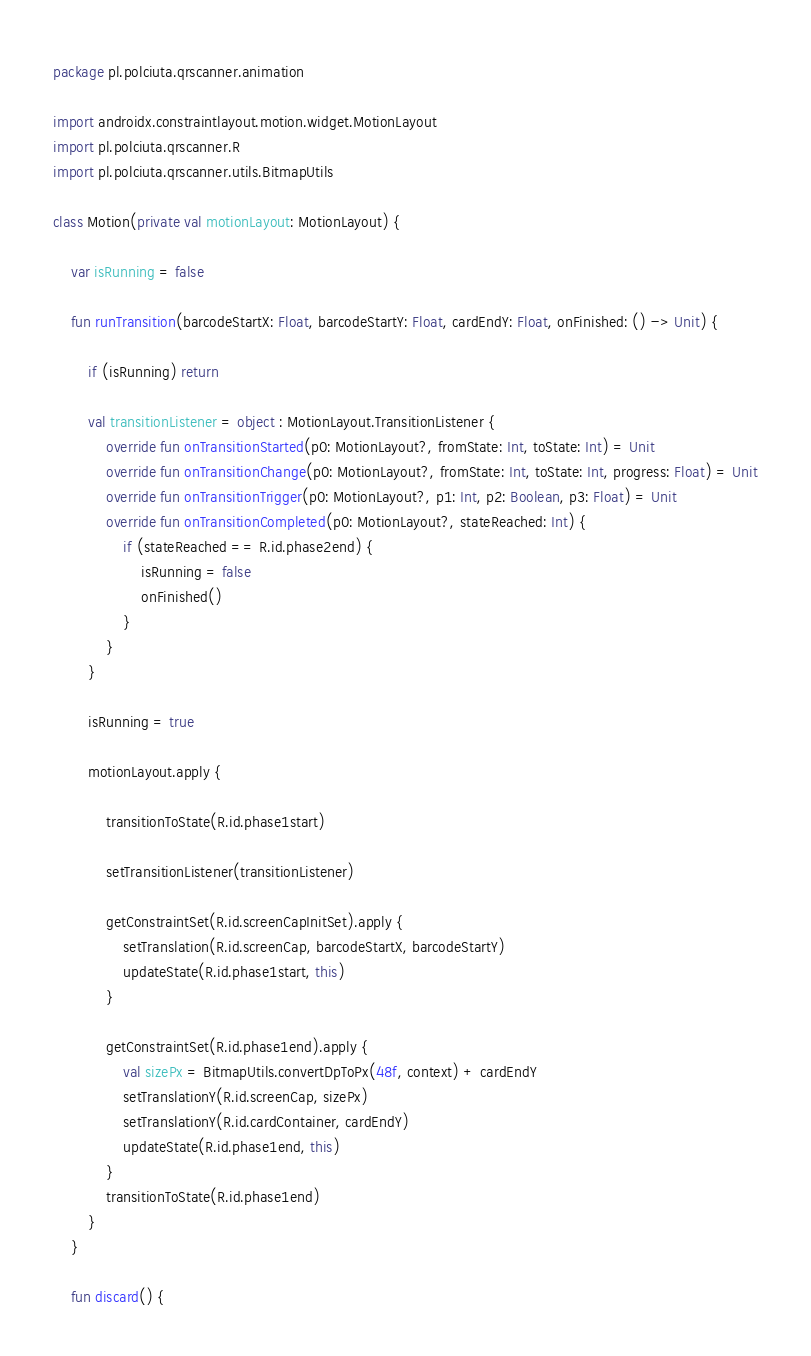Convert code to text. <code><loc_0><loc_0><loc_500><loc_500><_Kotlin_>package pl.polciuta.qrscanner.animation

import androidx.constraintlayout.motion.widget.MotionLayout
import pl.polciuta.qrscanner.R
import pl.polciuta.qrscanner.utils.BitmapUtils

class Motion(private val motionLayout: MotionLayout) {

    var isRunning = false

    fun runTransition(barcodeStartX: Float, barcodeStartY: Float, cardEndY: Float, onFinished: () -> Unit) {

        if (isRunning) return

        val transitionListener = object : MotionLayout.TransitionListener {
            override fun onTransitionStarted(p0: MotionLayout?, fromState: Int, toState: Int) = Unit
            override fun onTransitionChange(p0: MotionLayout?, fromState: Int, toState: Int, progress: Float) = Unit
            override fun onTransitionTrigger(p0: MotionLayout?, p1: Int, p2: Boolean, p3: Float) = Unit
            override fun onTransitionCompleted(p0: MotionLayout?, stateReached: Int) {
                if (stateReached == R.id.phase2end) {
                    isRunning = false
                    onFinished()
                }
            }
        }

        isRunning = true

        motionLayout.apply {

            transitionToState(R.id.phase1start)

            setTransitionListener(transitionListener)

            getConstraintSet(R.id.screenCapInitSet).apply {
                setTranslation(R.id.screenCap, barcodeStartX, barcodeStartY)
                updateState(R.id.phase1start, this)
            }

            getConstraintSet(R.id.phase1end).apply {
                val sizePx = BitmapUtils.convertDpToPx(48f, context) + cardEndY
                setTranslationY(R.id.screenCap, sizePx)
                setTranslationY(R.id.cardContainer, cardEndY)
                updateState(R.id.phase1end, this)
            }
            transitionToState(R.id.phase1end)
        }
    }

    fun discard() {</code> 